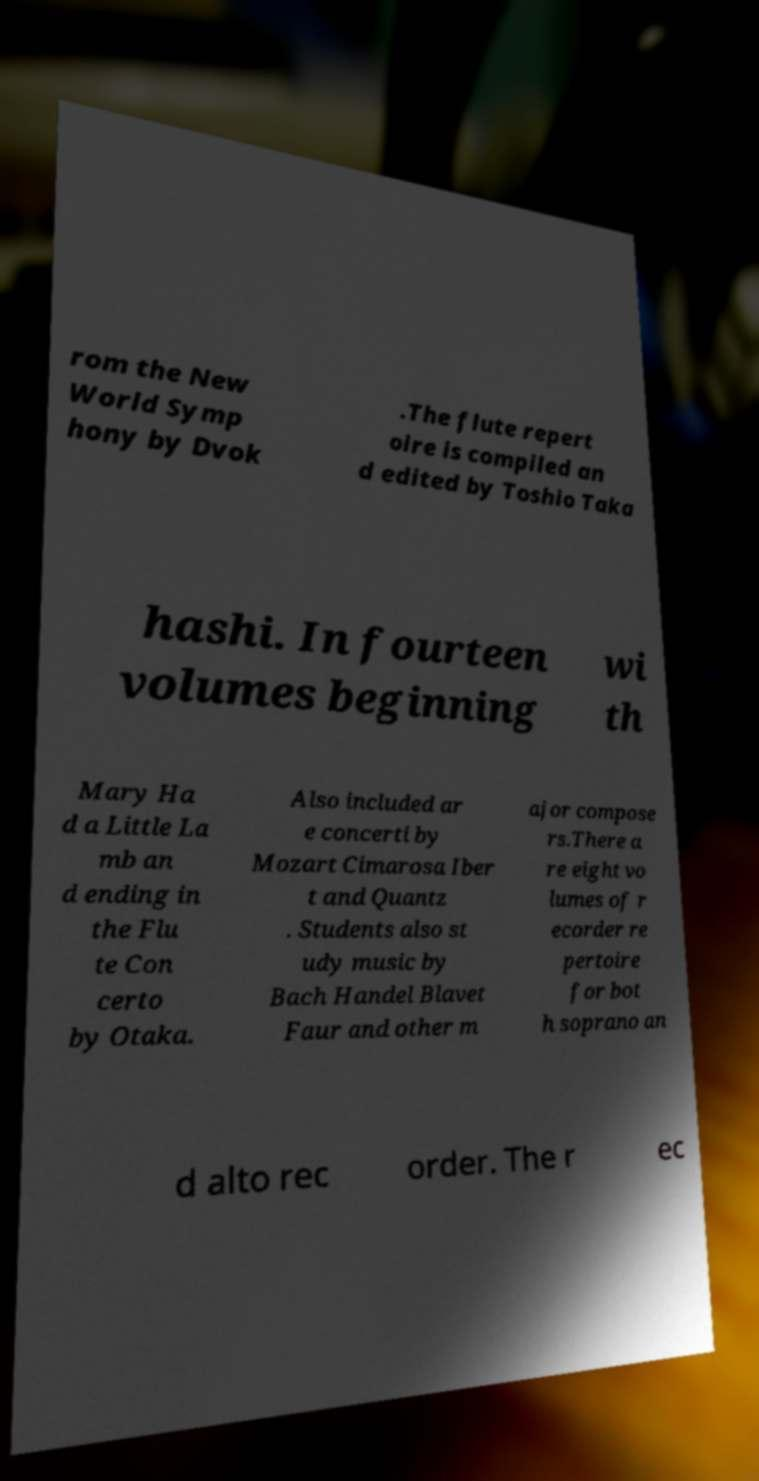Please identify and transcribe the text found in this image. rom the New World Symp hony by Dvok .The flute repert oire is compiled an d edited by Toshio Taka hashi. In fourteen volumes beginning wi th Mary Ha d a Little La mb an d ending in the Flu te Con certo by Otaka. Also included ar e concerti by Mozart Cimarosa Iber t and Quantz . Students also st udy music by Bach Handel Blavet Faur and other m ajor compose rs.There a re eight vo lumes of r ecorder re pertoire for bot h soprano an d alto rec order. The r ec 